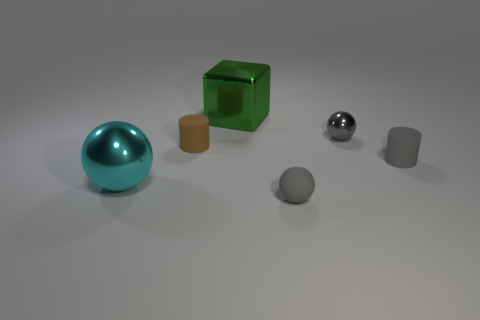Subtract all purple cubes. How many gray spheres are left? 2 Subtract all small gray spheres. How many spheres are left? 1 Add 2 big yellow matte spheres. How many objects exist? 8 Subtract all cylinders. How many objects are left? 4 Subtract all gray metal objects. Subtract all small matte cylinders. How many objects are left? 3 Add 5 cyan objects. How many cyan objects are left? 6 Add 1 brown rubber cylinders. How many brown rubber cylinders exist? 2 Subtract 0 red blocks. How many objects are left? 6 Subtract all green spheres. Subtract all cyan cubes. How many spheres are left? 3 